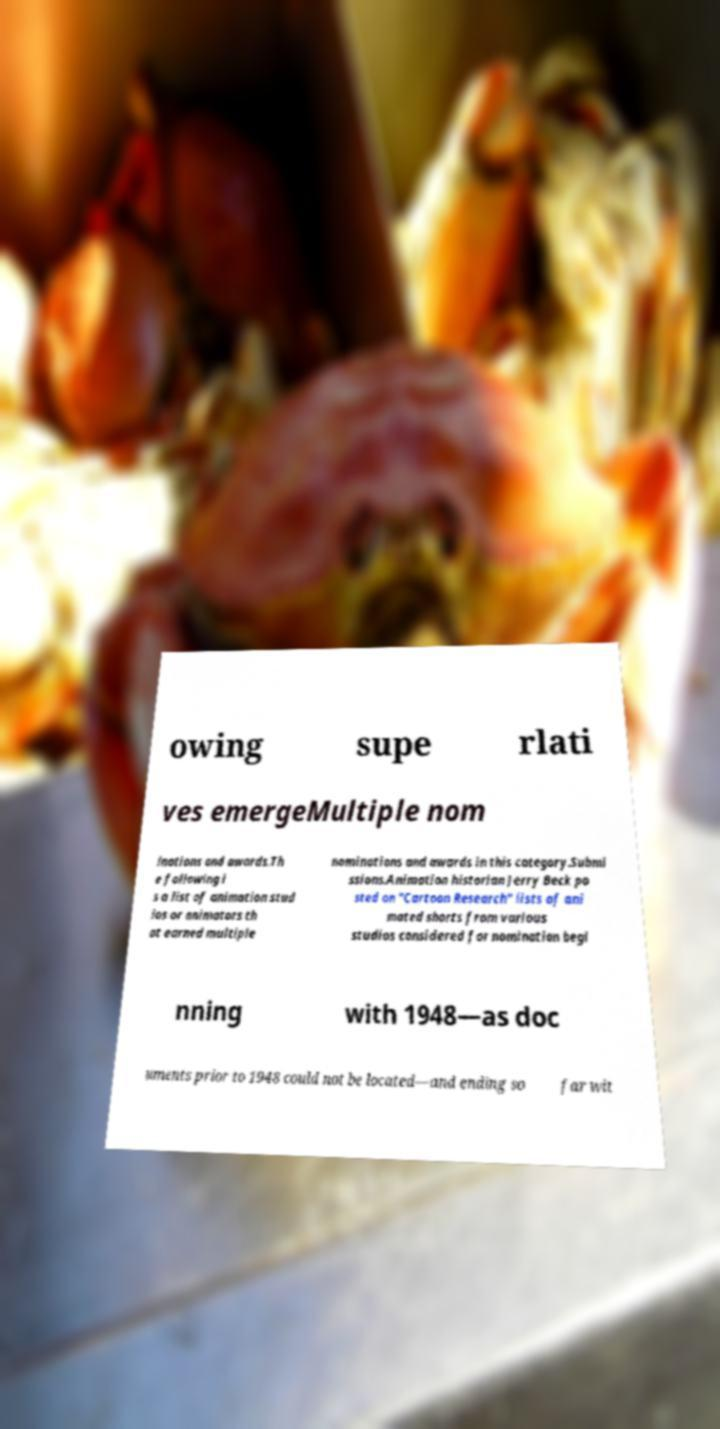I need the written content from this picture converted into text. Can you do that? owing supe rlati ves emergeMultiple nom inations and awards.Th e following i s a list of animation stud ios or animators th at earned multiple nominations and awards in this category.Submi ssions.Animation historian Jerry Beck po sted on "Cartoon Research" lists of ani mated shorts from various studios considered for nomination begi nning with 1948—as doc uments prior to 1948 could not be located—and ending so far wit 